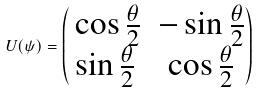Convert formula to latex. <formula><loc_0><loc_0><loc_500><loc_500>U ( \psi ) = \begin{pmatrix} \, \cos { \frac { \theta } { 2 } } & - \sin { \frac { \theta } { 2 } } \\ \sin { \frac { \theta } { 2 } } & \cos { \frac { \theta } { 2 } } \end{pmatrix} \,</formula> 